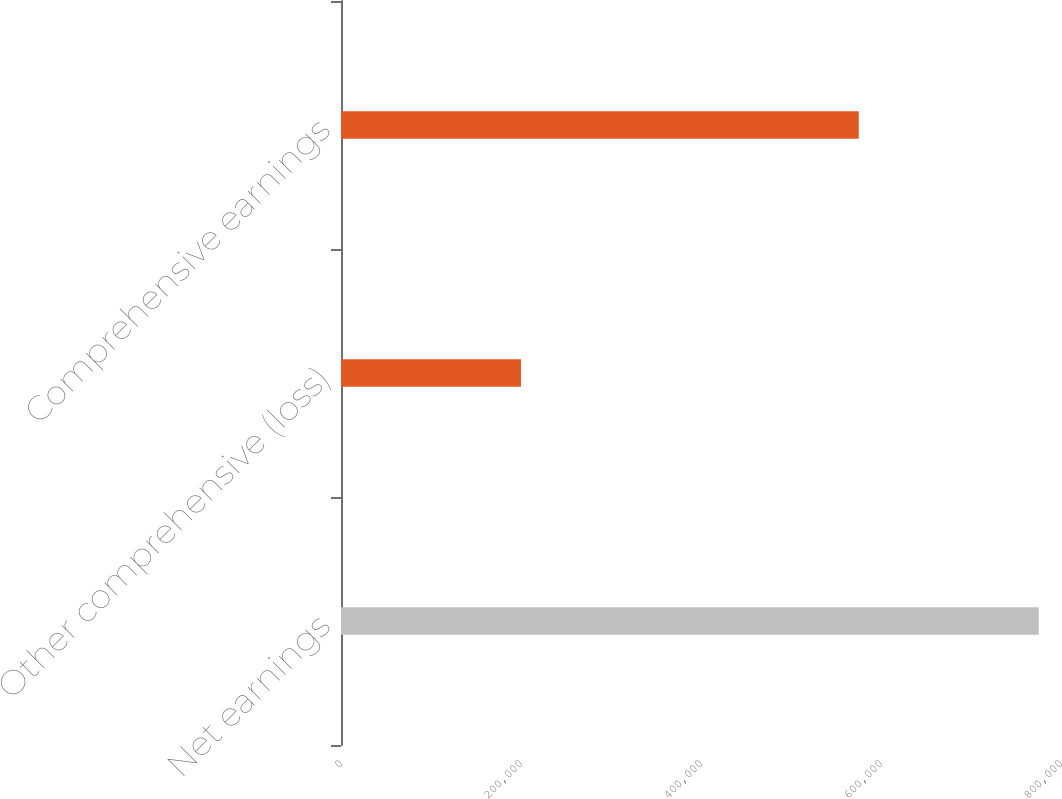Convert chart. <chart><loc_0><loc_0><loc_500><loc_500><bar_chart><fcel>Net earnings<fcel>Other comprehensive (loss)<fcel>Comprehensive earnings<nl><fcel>775235<fcel>199959<fcel>575276<nl></chart> 